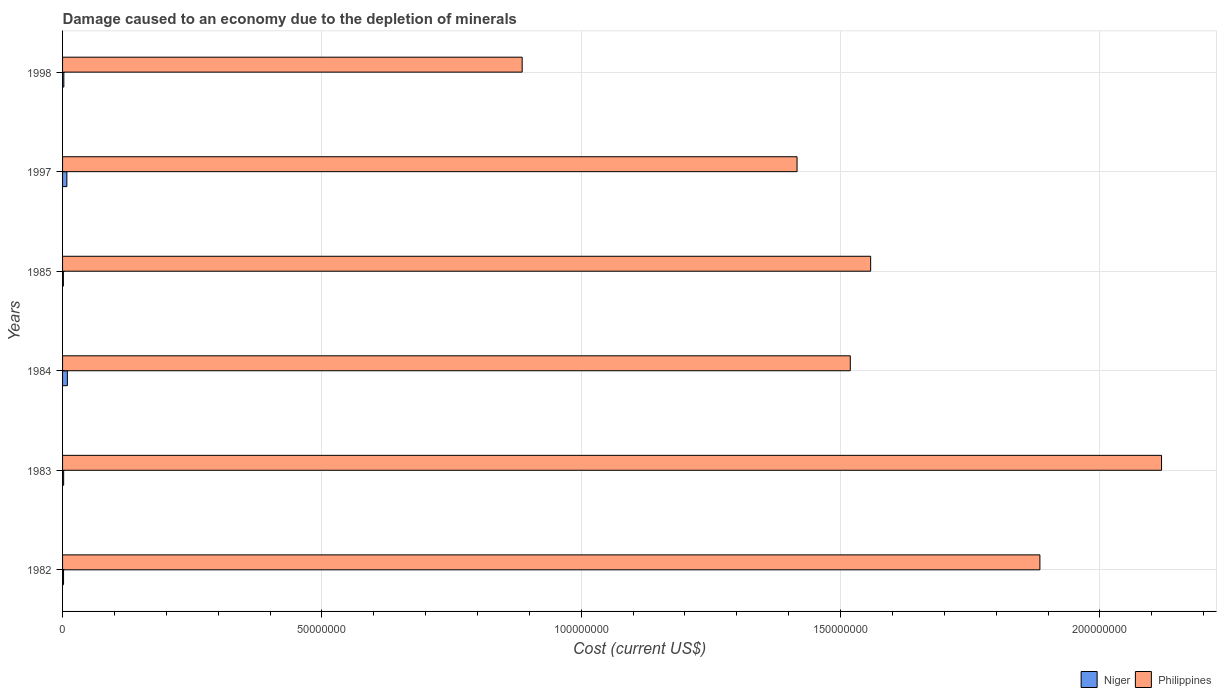How many different coloured bars are there?
Provide a succinct answer. 2. Are the number of bars on each tick of the Y-axis equal?
Make the answer very short. Yes. In how many cases, is the number of bars for a given year not equal to the number of legend labels?
Make the answer very short. 0. What is the cost of damage caused due to the depletion of minerals in Philippines in 1985?
Offer a very short reply. 1.56e+08. Across all years, what is the maximum cost of damage caused due to the depletion of minerals in Niger?
Your answer should be compact. 9.28e+05. Across all years, what is the minimum cost of damage caused due to the depletion of minerals in Niger?
Make the answer very short. 1.56e+05. What is the total cost of damage caused due to the depletion of minerals in Niger in the graph?
Your response must be concise. 2.56e+06. What is the difference between the cost of damage caused due to the depletion of minerals in Philippines in 1983 and that in 1997?
Offer a terse response. 7.03e+07. What is the difference between the cost of damage caused due to the depletion of minerals in Philippines in 1998 and the cost of damage caused due to the depletion of minerals in Niger in 1982?
Offer a very short reply. 8.84e+07. What is the average cost of damage caused due to the depletion of minerals in Philippines per year?
Your answer should be compact. 1.56e+08. In the year 1998, what is the difference between the cost of damage caused due to the depletion of minerals in Niger and cost of damage caused due to the depletion of minerals in Philippines?
Your answer should be very brief. -8.84e+07. In how many years, is the cost of damage caused due to the depletion of minerals in Philippines greater than 70000000 US$?
Ensure brevity in your answer.  6. What is the ratio of the cost of damage caused due to the depletion of minerals in Philippines in 1984 to that in 1985?
Provide a succinct answer. 0.97. Is the difference between the cost of damage caused due to the depletion of minerals in Niger in 1982 and 1997 greater than the difference between the cost of damage caused due to the depletion of minerals in Philippines in 1982 and 1997?
Offer a terse response. No. What is the difference between the highest and the second highest cost of damage caused due to the depletion of minerals in Philippines?
Offer a terse response. 2.35e+07. What is the difference between the highest and the lowest cost of damage caused due to the depletion of minerals in Philippines?
Your answer should be very brief. 1.23e+08. In how many years, is the cost of damage caused due to the depletion of minerals in Niger greater than the average cost of damage caused due to the depletion of minerals in Niger taken over all years?
Provide a short and direct response. 2. Is the sum of the cost of damage caused due to the depletion of minerals in Philippines in 1982 and 1984 greater than the maximum cost of damage caused due to the depletion of minerals in Niger across all years?
Your answer should be compact. Yes. What does the 2nd bar from the top in 1983 represents?
Provide a succinct answer. Niger. What does the 1st bar from the bottom in 1983 represents?
Ensure brevity in your answer.  Niger. How many bars are there?
Offer a terse response. 12. Are all the bars in the graph horizontal?
Offer a very short reply. Yes. What is the difference between two consecutive major ticks on the X-axis?
Offer a very short reply. 5.00e+07. Where does the legend appear in the graph?
Ensure brevity in your answer.  Bottom right. How are the legend labels stacked?
Give a very brief answer. Horizontal. What is the title of the graph?
Ensure brevity in your answer.  Damage caused to an economy due to the depletion of minerals. Does "Tonga" appear as one of the legend labels in the graph?
Provide a succinct answer. No. What is the label or title of the X-axis?
Offer a terse response. Cost (current US$). What is the label or title of the Y-axis?
Keep it short and to the point. Years. What is the Cost (current US$) in Niger in 1982?
Provide a succinct answer. 1.88e+05. What is the Cost (current US$) of Philippines in 1982?
Make the answer very short. 1.88e+08. What is the Cost (current US$) in Niger in 1983?
Offer a very short reply. 2.12e+05. What is the Cost (current US$) in Philippines in 1983?
Ensure brevity in your answer.  2.12e+08. What is the Cost (current US$) of Niger in 1984?
Ensure brevity in your answer.  9.28e+05. What is the Cost (current US$) in Philippines in 1984?
Ensure brevity in your answer.  1.52e+08. What is the Cost (current US$) in Niger in 1985?
Your answer should be very brief. 1.56e+05. What is the Cost (current US$) in Philippines in 1985?
Offer a very short reply. 1.56e+08. What is the Cost (current US$) in Niger in 1997?
Your answer should be very brief. 8.31e+05. What is the Cost (current US$) of Philippines in 1997?
Your response must be concise. 1.42e+08. What is the Cost (current US$) in Niger in 1998?
Offer a terse response. 2.46e+05. What is the Cost (current US$) of Philippines in 1998?
Your answer should be compact. 8.86e+07. Across all years, what is the maximum Cost (current US$) in Niger?
Ensure brevity in your answer.  9.28e+05. Across all years, what is the maximum Cost (current US$) of Philippines?
Offer a terse response. 2.12e+08. Across all years, what is the minimum Cost (current US$) in Niger?
Your answer should be very brief. 1.56e+05. Across all years, what is the minimum Cost (current US$) in Philippines?
Give a very brief answer. 8.86e+07. What is the total Cost (current US$) in Niger in the graph?
Give a very brief answer. 2.56e+06. What is the total Cost (current US$) of Philippines in the graph?
Your answer should be very brief. 9.38e+08. What is the difference between the Cost (current US$) in Niger in 1982 and that in 1983?
Provide a short and direct response. -2.36e+04. What is the difference between the Cost (current US$) of Philippines in 1982 and that in 1983?
Your answer should be compact. -2.35e+07. What is the difference between the Cost (current US$) in Niger in 1982 and that in 1984?
Keep it short and to the point. -7.40e+05. What is the difference between the Cost (current US$) in Philippines in 1982 and that in 1984?
Make the answer very short. 3.66e+07. What is the difference between the Cost (current US$) in Niger in 1982 and that in 1985?
Offer a very short reply. 3.17e+04. What is the difference between the Cost (current US$) in Philippines in 1982 and that in 1985?
Keep it short and to the point. 3.26e+07. What is the difference between the Cost (current US$) in Niger in 1982 and that in 1997?
Your response must be concise. -6.42e+05. What is the difference between the Cost (current US$) in Philippines in 1982 and that in 1997?
Offer a very short reply. 4.68e+07. What is the difference between the Cost (current US$) in Niger in 1982 and that in 1998?
Ensure brevity in your answer.  -5.77e+04. What is the difference between the Cost (current US$) of Philippines in 1982 and that in 1998?
Your answer should be very brief. 9.98e+07. What is the difference between the Cost (current US$) of Niger in 1983 and that in 1984?
Offer a terse response. -7.16e+05. What is the difference between the Cost (current US$) of Philippines in 1983 and that in 1984?
Your answer should be compact. 6.00e+07. What is the difference between the Cost (current US$) of Niger in 1983 and that in 1985?
Make the answer very short. 5.53e+04. What is the difference between the Cost (current US$) in Philippines in 1983 and that in 1985?
Offer a terse response. 5.61e+07. What is the difference between the Cost (current US$) of Niger in 1983 and that in 1997?
Your answer should be very brief. -6.19e+05. What is the difference between the Cost (current US$) of Philippines in 1983 and that in 1997?
Ensure brevity in your answer.  7.03e+07. What is the difference between the Cost (current US$) of Niger in 1983 and that in 1998?
Offer a terse response. -3.41e+04. What is the difference between the Cost (current US$) of Philippines in 1983 and that in 1998?
Make the answer very short. 1.23e+08. What is the difference between the Cost (current US$) of Niger in 1984 and that in 1985?
Provide a succinct answer. 7.71e+05. What is the difference between the Cost (current US$) in Philippines in 1984 and that in 1985?
Ensure brevity in your answer.  -3.92e+06. What is the difference between the Cost (current US$) of Niger in 1984 and that in 1997?
Provide a short and direct response. 9.72e+04. What is the difference between the Cost (current US$) of Philippines in 1984 and that in 1997?
Make the answer very short. 1.03e+07. What is the difference between the Cost (current US$) of Niger in 1984 and that in 1998?
Give a very brief answer. 6.82e+05. What is the difference between the Cost (current US$) of Philippines in 1984 and that in 1998?
Ensure brevity in your answer.  6.33e+07. What is the difference between the Cost (current US$) in Niger in 1985 and that in 1997?
Provide a succinct answer. -6.74e+05. What is the difference between the Cost (current US$) of Philippines in 1985 and that in 1997?
Offer a terse response. 1.42e+07. What is the difference between the Cost (current US$) of Niger in 1985 and that in 1998?
Your answer should be compact. -8.94e+04. What is the difference between the Cost (current US$) in Philippines in 1985 and that in 1998?
Ensure brevity in your answer.  6.72e+07. What is the difference between the Cost (current US$) in Niger in 1997 and that in 1998?
Offer a terse response. 5.85e+05. What is the difference between the Cost (current US$) in Philippines in 1997 and that in 1998?
Offer a terse response. 5.30e+07. What is the difference between the Cost (current US$) of Niger in 1982 and the Cost (current US$) of Philippines in 1983?
Give a very brief answer. -2.12e+08. What is the difference between the Cost (current US$) of Niger in 1982 and the Cost (current US$) of Philippines in 1984?
Keep it short and to the point. -1.52e+08. What is the difference between the Cost (current US$) of Niger in 1982 and the Cost (current US$) of Philippines in 1985?
Your response must be concise. -1.56e+08. What is the difference between the Cost (current US$) in Niger in 1982 and the Cost (current US$) in Philippines in 1997?
Keep it short and to the point. -1.41e+08. What is the difference between the Cost (current US$) in Niger in 1982 and the Cost (current US$) in Philippines in 1998?
Provide a succinct answer. -8.84e+07. What is the difference between the Cost (current US$) in Niger in 1983 and the Cost (current US$) in Philippines in 1984?
Provide a short and direct response. -1.52e+08. What is the difference between the Cost (current US$) of Niger in 1983 and the Cost (current US$) of Philippines in 1985?
Your answer should be compact. -1.56e+08. What is the difference between the Cost (current US$) of Niger in 1983 and the Cost (current US$) of Philippines in 1997?
Offer a very short reply. -1.41e+08. What is the difference between the Cost (current US$) in Niger in 1983 and the Cost (current US$) in Philippines in 1998?
Offer a very short reply. -8.84e+07. What is the difference between the Cost (current US$) in Niger in 1984 and the Cost (current US$) in Philippines in 1985?
Ensure brevity in your answer.  -1.55e+08. What is the difference between the Cost (current US$) in Niger in 1984 and the Cost (current US$) in Philippines in 1997?
Keep it short and to the point. -1.41e+08. What is the difference between the Cost (current US$) in Niger in 1984 and the Cost (current US$) in Philippines in 1998?
Offer a terse response. -8.77e+07. What is the difference between the Cost (current US$) in Niger in 1985 and the Cost (current US$) in Philippines in 1997?
Your answer should be very brief. -1.41e+08. What is the difference between the Cost (current US$) in Niger in 1985 and the Cost (current US$) in Philippines in 1998?
Make the answer very short. -8.85e+07. What is the difference between the Cost (current US$) in Niger in 1997 and the Cost (current US$) in Philippines in 1998?
Give a very brief answer. -8.78e+07. What is the average Cost (current US$) of Niger per year?
Provide a succinct answer. 4.27e+05. What is the average Cost (current US$) in Philippines per year?
Your answer should be very brief. 1.56e+08. In the year 1982, what is the difference between the Cost (current US$) in Niger and Cost (current US$) in Philippines?
Ensure brevity in your answer.  -1.88e+08. In the year 1983, what is the difference between the Cost (current US$) in Niger and Cost (current US$) in Philippines?
Your answer should be very brief. -2.12e+08. In the year 1984, what is the difference between the Cost (current US$) of Niger and Cost (current US$) of Philippines?
Provide a succinct answer. -1.51e+08. In the year 1985, what is the difference between the Cost (current US$) in Niger and Cost (current US$) in Philippines?
Provide a short and direct response. -1.56e+08. In the year 1997, what is the difference between the Cost (current US$) in Niger and Cost (current US$) in Philippines?
Give a very brief answer. -1.41e+08. In the year 1998, what is the difference between the Cost (current US$) of Niger and Cost (current US$) of Philippines?
Make the answer very short. -8.84e+07. What is the ratio of the Cost (current US$) of Niger in 1982 to that in 1983?
Keep it short and to the point. 0.89. What is the ratio of the Cost (current US$) of Philippines in 1982 to that in 1983?
Keep it short and to the point. 0.89. What is the ratio of the Cost (current US$) in Niger in 1982 to that in 1984?
Your answer should be compact. 0.2. What is the ratio of the Cost (current US$) of Philippines in 1982 to that in 1984?
Keep it short and to the point. 1.24. What is the ratio of the Cost (current US$) in Niger in 1982 to that in 1985?
Offer a terse response. 1.2. What is the ratio of the Cost (current US$) of Philippines in 1982 to that in 1985?
Ensure brevity in your answer.  1.21. What is the ratio of the Cost (current US$) in Niger in 1982 to that in 1997?
Provide a succinct answer. 0.23. What is the ratio of the Cost (current US$) of Philippines in 1982 to that in 1997?
Your response must be concise. 1.33. What is the ratio of the Cost (current US$) in Niger in 1982 to that in 1998?
Offer a terse response. 0.77. What is the ratio of the Cost (current US$) in Philippines in 1982 to that in 1998?
Provide a succinct answer. 2.13. What is the ratio of the Cost (current US$) in Niger in 1983 to that in 1984?
Your answer should be very brief. 0.23. What is the ratio of the Cost (current US$) in Philippines in 1983 to that in 1984?
Your response must be concise. 1.4. What is the ratio of the Cost (current US$) in Niger in 1983 to that in 1985?
Give a very brief answer. 1.35. What is the ratio of the Cost (current US$) of Philippines in 1983 to that in 1985?
Your response must be concise. 1.36. What is the ratio of the Cost (current US$) in Niger in 1983 to that in 1997?
Ensure brevity in your answer.  0.25. What is the ratio of the Cost (current US$) in Philippines in 1983 to that in 1997?
Offer a very short reply. 1.5. What is the ratio of the Cost (current US$) of Niger in 1983 to that in 1998?
Your response must be concise. 0.86. What is the ratio of the Cost (current US$) in Philippines in 1983 to that in 1998?
Your answer should be very brief. 2.39. What is the ratio of the Cost (current US$) in Niger in 1984 to that in 1985?
Ensure brevity in your answer.  5.94. What is the ratio of the Cost (current US$) of Philippines in 1984 to that in 1985?
Make the answer very short. 0.97. What is the ratio of the Cost (current US$) in Niger in 1984 to that in 1997?
Give a very brief answer. 1.12. What is the ratio of the Cost (current US$) in Philippines in 1984 to that in 1997?
Give a very brief answer. 1.07. What is the ratio of the Cost (current US$) of Niger in 1984 to that in 1998?
Ensure brevity in your answer.  3.78. What is the ratio of the Cost (current US$) in Philippines in 1984 to that in 1998?
Give a very brief answer. 1.71. What is the ratio of the Cost (current US$) in Niger in 1985 to that in 1997?
Keep it short and to the point. 0.19. What is the ratio of the Cost (current US$) in Philippines in 1985 to that in 1997?
Offer a very short reply. 1.1. What is the ratio of the Cost (current US$) of Niger in 1985 to that in 1998?
Offer a very short reply. 0.64. What is the ratio of the Cost (current US$) in Philippines in 1985 to that in 1998?
Your response must be concise. 1.76. What is the ratio of the Cost (current US$) in Niger in 1997 to that in 1998?
Make the answer very short. 3.38. What is the ratio of the Cost (current US$) of Philippines in 1997 to that in 1998?
Provide a short and direct response. 1.6. What is the difference between the highest and the second highest Cost (current US$) in Niger?
Offer a very short reply. 9.72e+04. What is the difference between the highest and the second highest Cost (current US$) of Philippines?
Offer a very short reply. 2.35e+07. What is the difference between the highest and the lowest Cost (current US$) in Niger?
Your answer should be compact. 7.71e+05. What is the difference between the highest and the lowest Cost (current US$) of Philippines?
Your answer should be compact. 1.23e+08. 